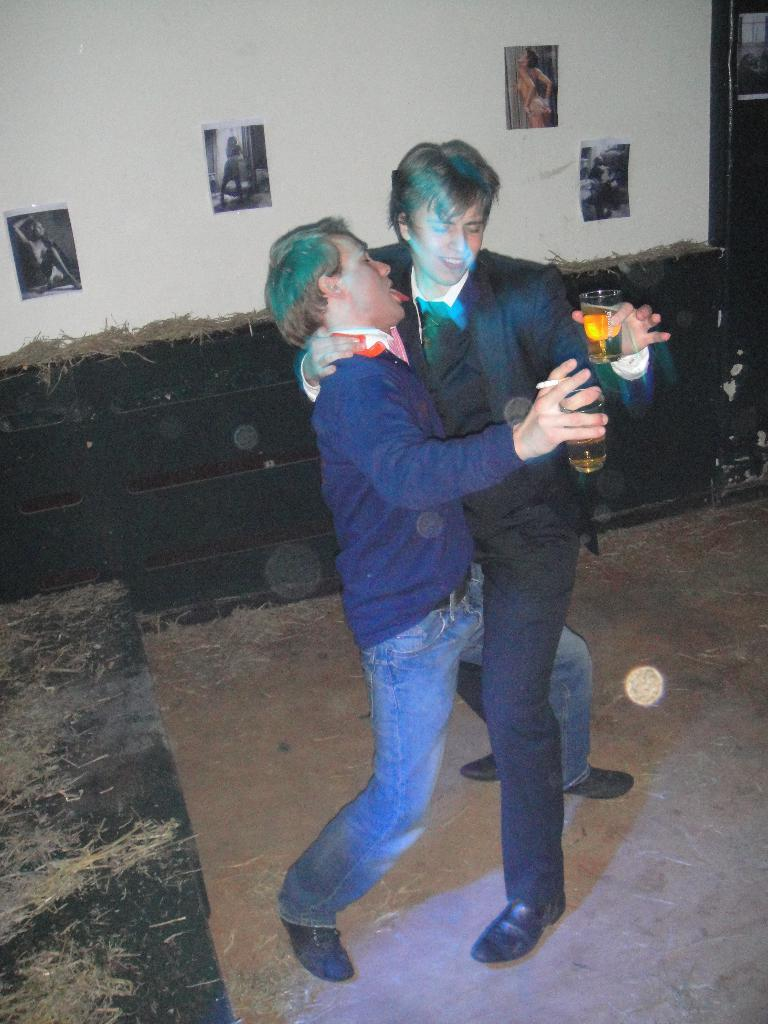How many people are in the image? There are two men in the image. What are the men doing in the image? The men are dancing. What are the men holding in their hands? The men are holding glasses in their hands. What can be seen on the wall in the image? There are posts on the wall in the image. How many cars are parked in the bathroom in the image? There are no cars or bathrooms present in the image; it features two men dancing and holding glasses. 